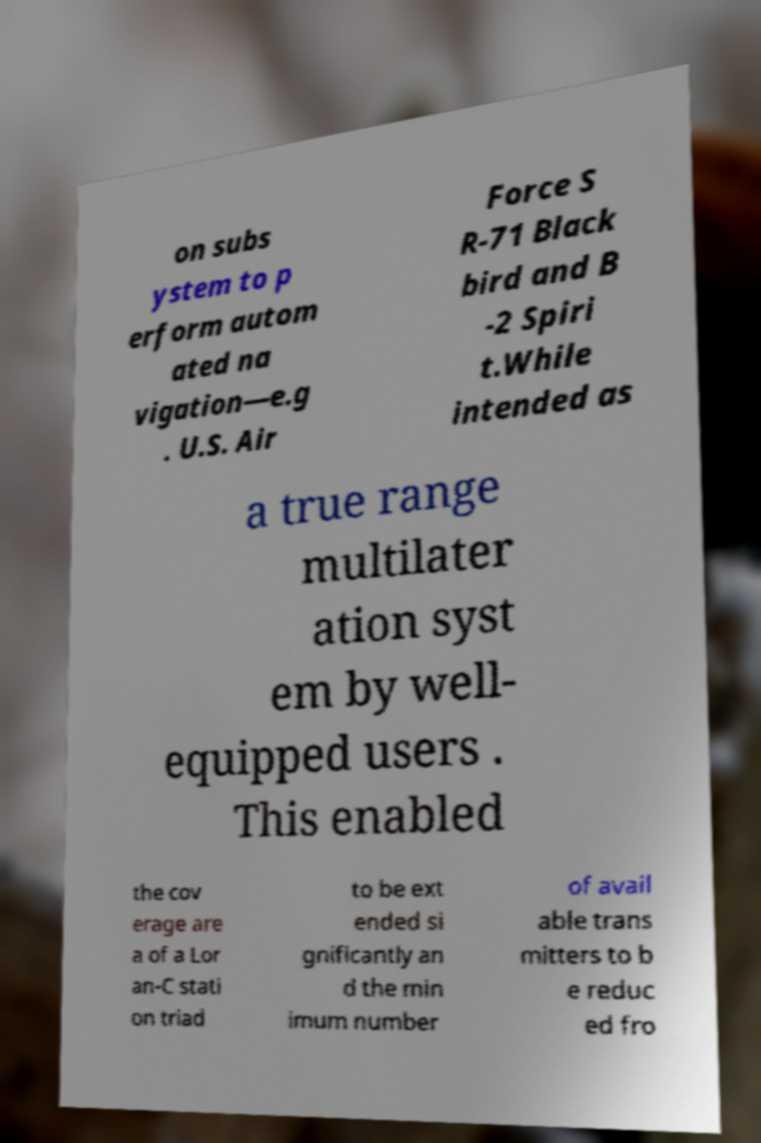Please identify and transcribe the text found in this image. on subs ystem to p erform autom ated na vigation—e.g . U.S. Air Force S R-71 Black bird and B -2 Spiri t.While intended as a true range multilater ation syst em by well- equipped users . This enabled the cov erage are a of a Lor an-C stati on triad to be ext ended si gnificantly an d the min imum number of avail able trans mitters to b e reduc ed fro 